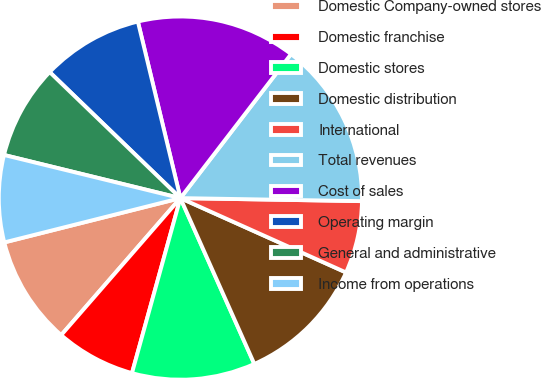<chart> <loc_0><loc_0><loc_500><loc_500><pie_chart><fcel>Domestic Company-owned stores<fcel>Domestic franchise<fcel>Domestic stores<fcel>Domestic distribution<fcel>International<fcel>Total revenues<fcel>Cost of sales<fcel>Operating margin<fcel>General and administrative<fcel>Income from operations<nl><fcel>9.68%<fcel>7.1%<fcel>10.97%<fcel>11.61%<fcel>6.45%<fcel>14.84%<fcel>14.19%<fcel>9.03%<fcel>8.39%<fcel>7.74%<nl></chart> 